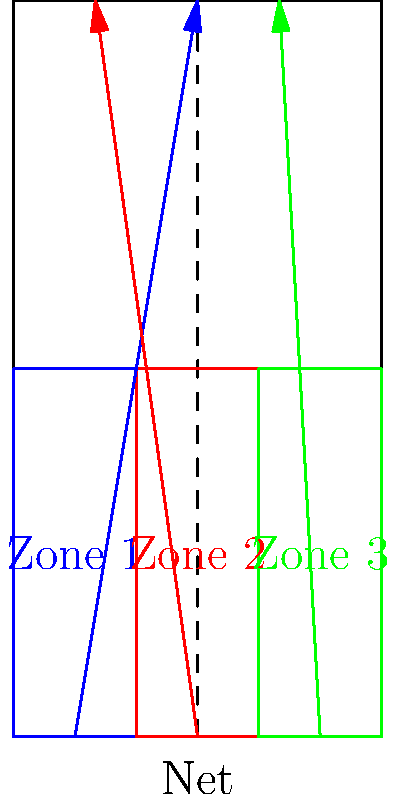Analyze the volleyball serve patterns represented in the court diagram. Which serve trajectory is most likely to create difficulties for the receiving team's libero, and why? To answer this question, we need to analyze the serve trajectories from each zone and their implications:

1. Zone 1 (Blue): The serve follows a diagonal path from the left side to the right side of the court. This serve crosses the entire court, potentially pulling the libero out of position.

2. Zone 2 (Red): The serve starts from the center and moves towards the left side of the court. This serve has a shorter trajectory and stays on one side of the court.

3. Zone 3 (Green): The serve follows a relatively straight path from the right side to the right side of the court. This serve maintains a consistent trajectory on one side.

The serve from Zone 1 (Blue) is most likely to create difficulties for the receiving team's libero because:

a) It covers the longest distance across the court, giving the ball more time to develop speed and unpredictable movement.
b) The diagonal trajectory forces the libero to move across the court, potentially creating positioning challenges.
c) The serve's path may create confusion between the libero and other receivers, increasing the chance of miscommunication.
d) The angle of the serve makes it harder for the libero to judge its depth and speed accurately.

In contrast, the serves from Zones 2 and 3 have more predictable trajectories, allowing the libero to position themselves more effectively.
Answer: Zone 1 (Blue) serve 